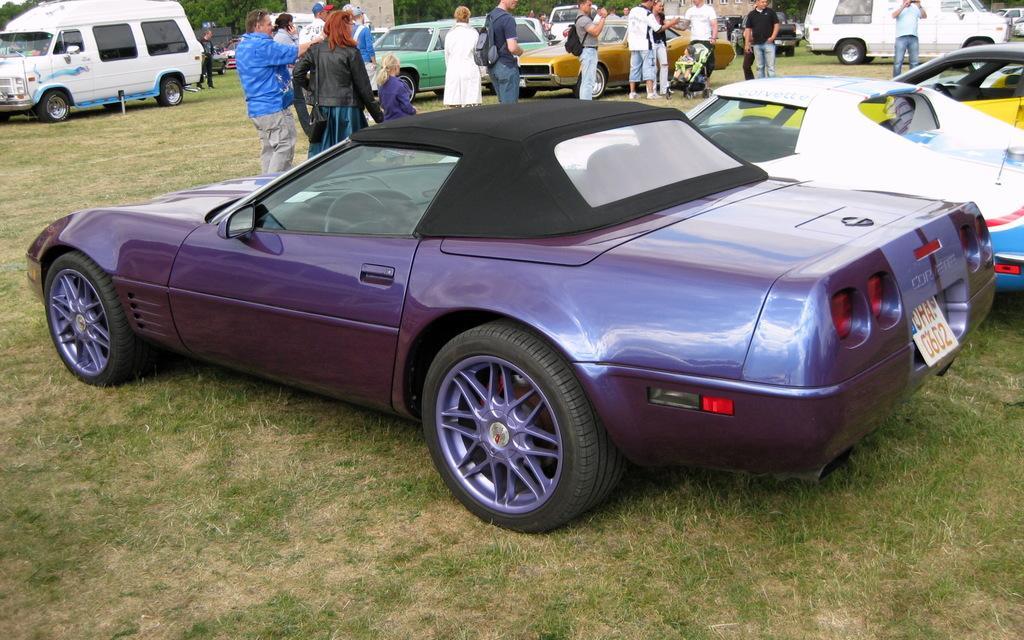Can you describe this image briefly? In this picture I can see a car is parked, it is in brinjal color. At the top few people are walking on this grass, on the right side few vehicles are parked. 